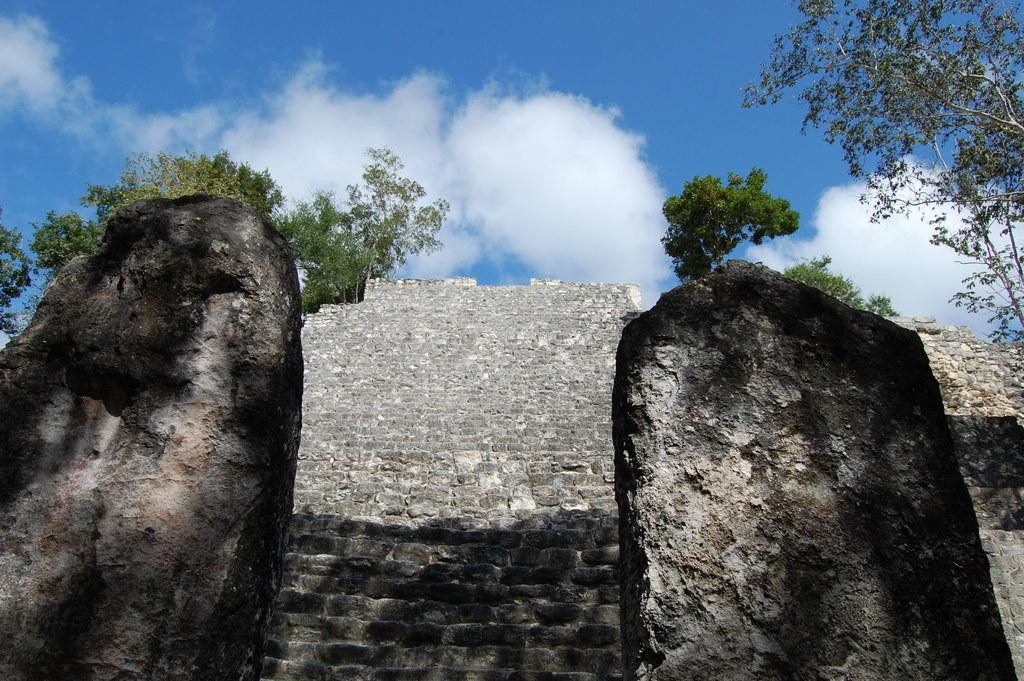What type of structure is present in the image? There are stairs in the image. What other objects can be seen in the image? There are rocks in the image. What can be seen in the background of the image? There are trees and the sky visible in the background of the image. What is the color of the trees in the image? The trees are green in color. What is the color of the sky in the image? The sky is blue and white in color. How many brothers are sitting on the rocks in the image? There are no brothers present in the image; it only features stairs, rocks, trees, and the sky. 